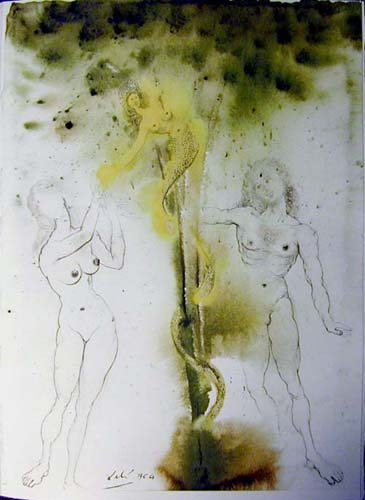Can you discuss the significance of the figures being depicted nude? The nudity of the figures strips away any cultural or historical context, focusing the viewer's attention on the form and emotional state of the figures. It speaks to universal vulnerability, representing the figures as raw and open to interpretation, which aligns with surrealism's aim to tap into the subconscious mind. 